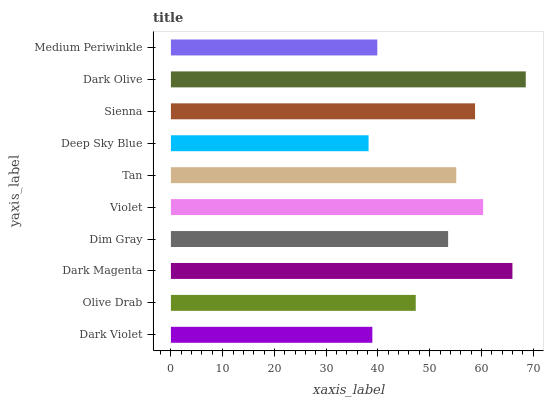Is Deep Sky Blue the minimum?
Answer yes or no. Yes. Is Dark Olive the maximum?
Answer yes or no. Yes. Is Olive Drab the minimum?
Answer yes or no. No. Is Olive Drab the maximum?
Answer yes or no. No. Is Olive Drab greater than Dark Violet?
Answer yes or no. Yes. Is Dark Violet less than Olive Drab?
Answer yes or no. Yes. Is Dark Violet greater than Olive Drab?
Answer yes or no. No. Is Olive Drab less than Dark Violet?
Answer yes or no. No. Is Tan the high median?
Answer yes or no. Yes. Is Dim Gray the low median?
Answer yes or no. Yes. Is Medium Periwinkle the high median?
Answer yes or no. No. Is Deep Sky Blue the low median?
Answer yes or no. No. 